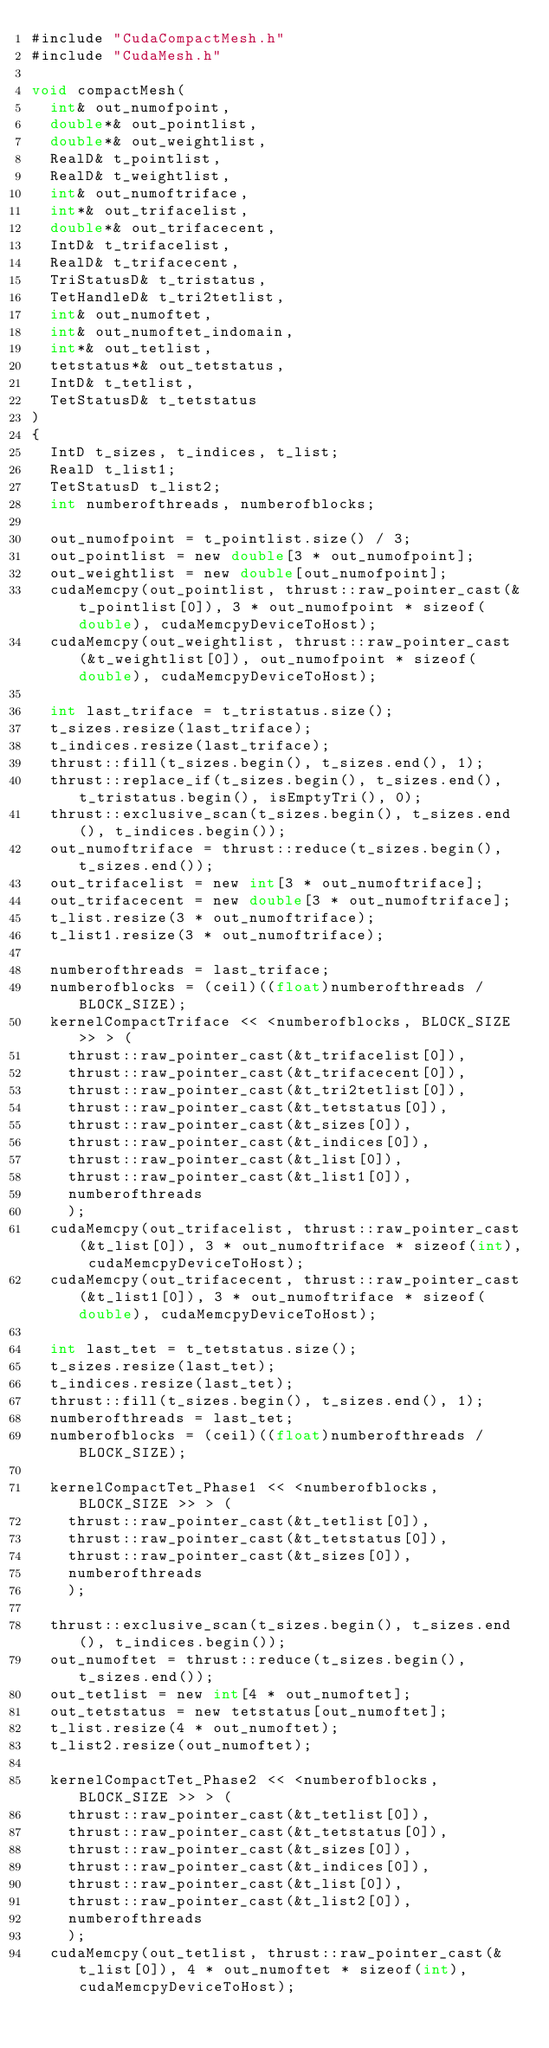Convert code to text. <code><loc_0><loc_0><loc_500><loc_500><_Cuda_>#include "CudaCompactMesh.h"
#include "CudaMesh.h"

void compactMesh(
	int& out_numofpoint,
	double*& out_pointlist,
	double*& out_weightlist,
	RealD& t_pointlist,
	RealD& t_weightlist,
	int& out_numoftriface,
	int*& out_trifacelist,
	double*& out_trifacecent,
	IntD& t_trifacelist,
	RealD& t_trifacecent,
	TriStatusD& t_tristatus,
	TetHandleD& t_tri2tetlist,
	int& out_numoftet,
	int& out_numoftet_indomain,
	int*& out_tetlist,
	tetstatus*& out_tetstatus,
	IntD& t_tetlist,
	TetStatusD& t_tetstatus
)
{
	IntD t_sizes, t_indices, t_list;
	RealD t_list1;
	TetStatusD t_list2;
	int numberofthreads, numberofblocks;

	out_numofpoint = t_pointlist.size() / 3;
	out_pointlist = new double[3 * out_numofpoint];
	out_weightlist = new double[out_numofpoint];
	cudaMemcpy(out_pointlist, thrust::raw_pointer_cast(&t_pointlist[0]), 3 * out_numofpoint * sizeof(double), cudaMemcpyDeviceToHost);
	cudaMemcpy(out_weightlist, thrust::raw_pointer_cast(&t_weightlist[0]), out_numofpoint * sizeof(double), cudaMemcpyDeviceToHost);

	int last_triface = t_tristatus.size();
	t_sizes.resize(last_triface);
	t_indices.resize(last_triface);
	thrust::fill(t_sizes.begin(), t_sizes.end(), 1);
	thrust::replace_if(t_sizes.begin(), t_sizes.end(), t_tristatus.begin(), isEmptyTri(), 0);
	thrust::exclusive_scan(t_sizes.begin(), t_sizes.end(), t_indices.begin());
	out_numoftriface = thrust::reduce(t_sizes.begin(), t_sizes.end());
	out_trifacelist = new int[3 * out_numoftriface];
	out_trifacecent = new double[3 * out_numoftriface];
	t_list.resize(3 * out_numoftriface);
	t_list1.resize(3 * out_numoftriface);

	numberofthreads = last_triface;
	numberofblocks = (ceil)((float)numberofthreads / BLOCK_SIZE);
	kernelCompactTriface << <numberofblocks, BLOCK_SIZE >> > (
		thrust::raw_pointer_cast(&t_trifacelist[0]),
		thrust::raw_pointer_cast(&t_trifacecent[0]),
		thrust::raw_pointer_cast(&t_tri2tetlist[0]),
		thrust::raw_pointer_cast(&t_tetstatus[0]),
		thrust::raw_pointer_cast(&t_sizes[0]),
		thrust::raw_pointer_cast(&t_indices[0]),
		thrust::raw_pointer_cast(&t_list[0]),
		thrust::raw_pointer_cast(&t_list1[0]),
		numberofthreads
		);
	cudaMemcpy(out_trifacelist, thrust::raw_pointer_cast(&t_list[0]), 3 * out_numoftriface * sizeof(int), cudaMemcpyDeviceToHost);
	cudaMemcpy(out_trifacecent, thrust::raw_pointer_cast(&t_list1[0]), 3 * out_numoftriface * sizeof(double), cudaMemcpyDeviceToHost);

	int last_tet = t_tetstatus.size();
	t_sizes.resize(last_tet);
	t_indices.resize(last_tet);
	thrust::fill(t_sizes.begin(), t_sizes.end(), 1);
	numberofthreads = last_tet;
	numberofblocks = (ceil)((float)numberofthreads / BLOCK_SIZE);

	kernelCompactTet_Phase1 << <numberofblocks, BLOCK_SIZE >> > (
		thrust::raw_pointer_cast(&t_tetlist[0]),
		thrust::raw_pointer_cast(&t_tetstatus[0]),
		thrust::raw_pointer_cast(&t_sizes[0]),
		numberofthreads
		);

	thrust::exclusive_scan(t_sizes.begin(), t_sizes.end(), t_indices.begin());
	out_numoftet = thrust::reduce(t_sizes.begin(), t_sizes.end());
	out_tetlist = new int[4 * out_numoftet];
	out_tetstatus = new tetstatus[out_numoftet];
	t_list.resize(4 * out_numoftet);
	t_list2.resize(out_numoftet);

	kernelCompactTet_Phase2 << <numberofblocks, BLOCK_SIZE >> > (
		thrust::raw_pointer_cast(&t_tetlist[0]),
		thrust::raw_pointer_cast(&t_tetstatus[0]),
		thrust::raw_pointer_cast(&t_sizes[0]),
		thrust::raw_pointer_cast(&t_indices[0]),
		thrust::raw_pointer_cast(&t_list[0]),
		thrust::raw_pointer_cast(&t_list2[0]),
		numberofthreads
		);
	cudaMemcpy(out_tetlist, thrust::raw_pointer_cast(&t_list[0]), 4 * out_numoftet * sizeof(int), cudaMemcpyDeviceToHost);</code> 